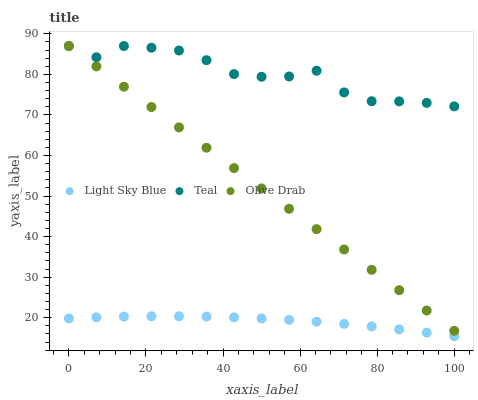Does Light Sky Blue have the minimum area under the curve?
Answer yes or no. Yes. Does Teal have the maximum area under the curve?
Answer yes or no. Yes. Does Olive Drab have the minimum area under the curve?
Answer yes or no. No. Does Olive Drab have the maximum area under the curve?
Answer yes or no. No. Is Olive Drab the smoothest?
Answer yes or no. Yes. Is Teal the roughest?
Answer yes or no. Yes. Is Teal the smoothest?
Answer yes or no. No. Is Olive Drab the roughest?
Answer yes or no. No. Does Light Sky Blue have the lowest value?
Answer yes or no. Yes. Does Olive Drab have the lowest value?
Answer yes or no. No. Does Teal have the highest value?
Answer yes or no. Yes. Is Light Sky Blue less than Olive Drab?
Answer yes or no. Yes. Is Olive Drab greater than Light Sky Blue?
Answer yes or no. Yes. Does Teal intersect Olive Drab?
Answer yes or no. Yes. Is Teal less than Olive Drab?
Answer yes or no. No. Is Teal greater than Olive Drab?
Answer yes or no. No. Does Light Sky Blue intersect Olive Drab?
Answer yes or no. No. 